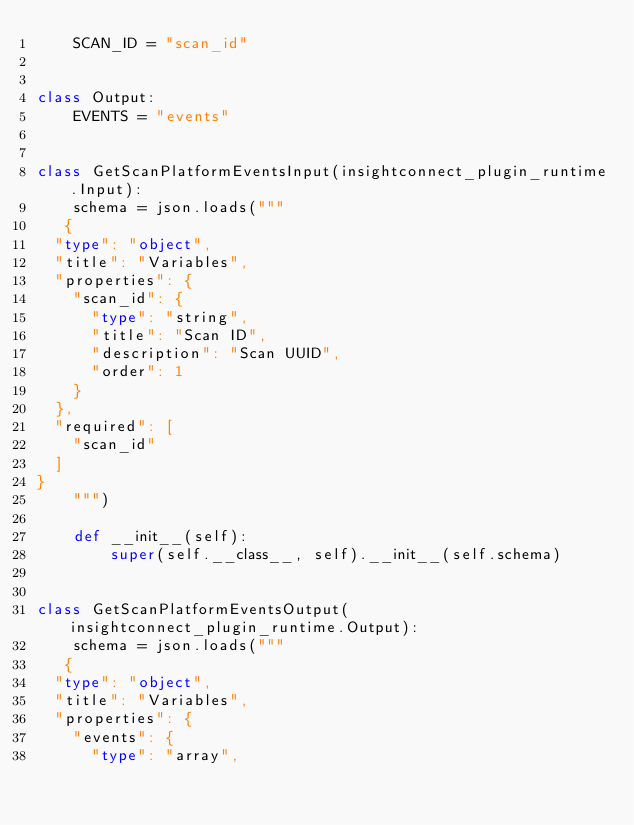<code> <loc_0><loc_0><loc_500><loc_500><_Python_>    SCAN_ID = "scan_id"
    

class Output:
    EVENTS = "events"
    

class GetScanPlatformEventsInput(insightconnect_plugin_runtime.Input):
    schema = json.loads("""
   {
  "type": "object",
  "title": "Variables",
  "properties": {
    "scan_id": {
      "type": "string",
      "title": "Scan ID",
      "description": "Scan UUID",
      "order": 1
    }
  },
  "required": [
    "scan_id"
  ]
}
    """)

    def __init__(self):
        super(self.__class__, self).__init__(self.schema)


class GetScanPlatformEventsOutput(insightconnect_plugin_runtime.Output):
    schema = json.loads("""
   {
  "type": "object",
  "title": "Variables",
  "properties": {
    "events": {
      "type": "array",</code> 